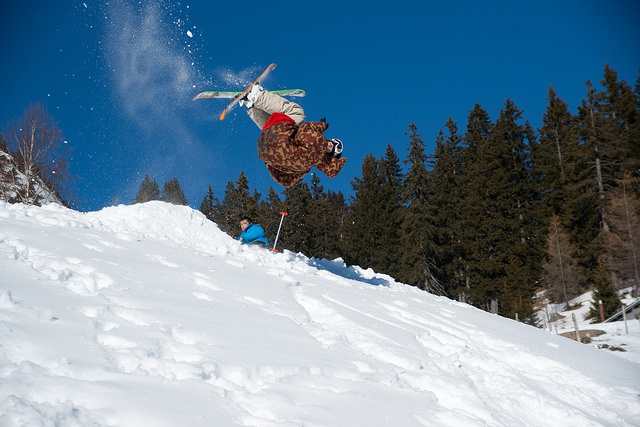Describe the objects in this image and their specific colors. I can see people in navy, maroon, black, brown, and gray tones, skis in navy, darkgray, gray, blue, and green tones, and people in navy, teal, black, and blue tones in this image. 